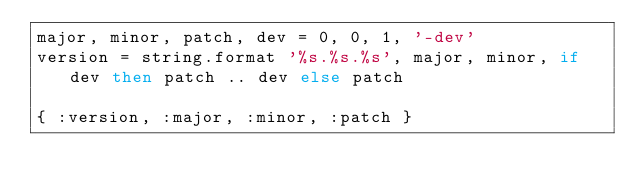<code> <loc_0><loc_0><loc_500><loc_500><_MoonScript_>major, minor, patch, dev = 0, 0, 1, '-dev'
version = string.format '%s.%s.%s', major, minor, if dev then patch .. dev else patch

{ :version, :major, :minor, :patch }
</code> 